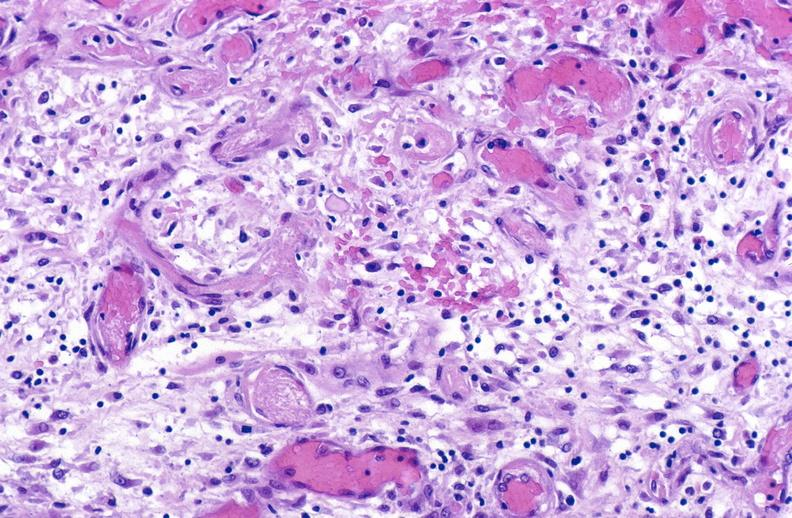does seminoma show tracheotomy site, granulation tissue?
Answer the question using a single word or phrase. No 